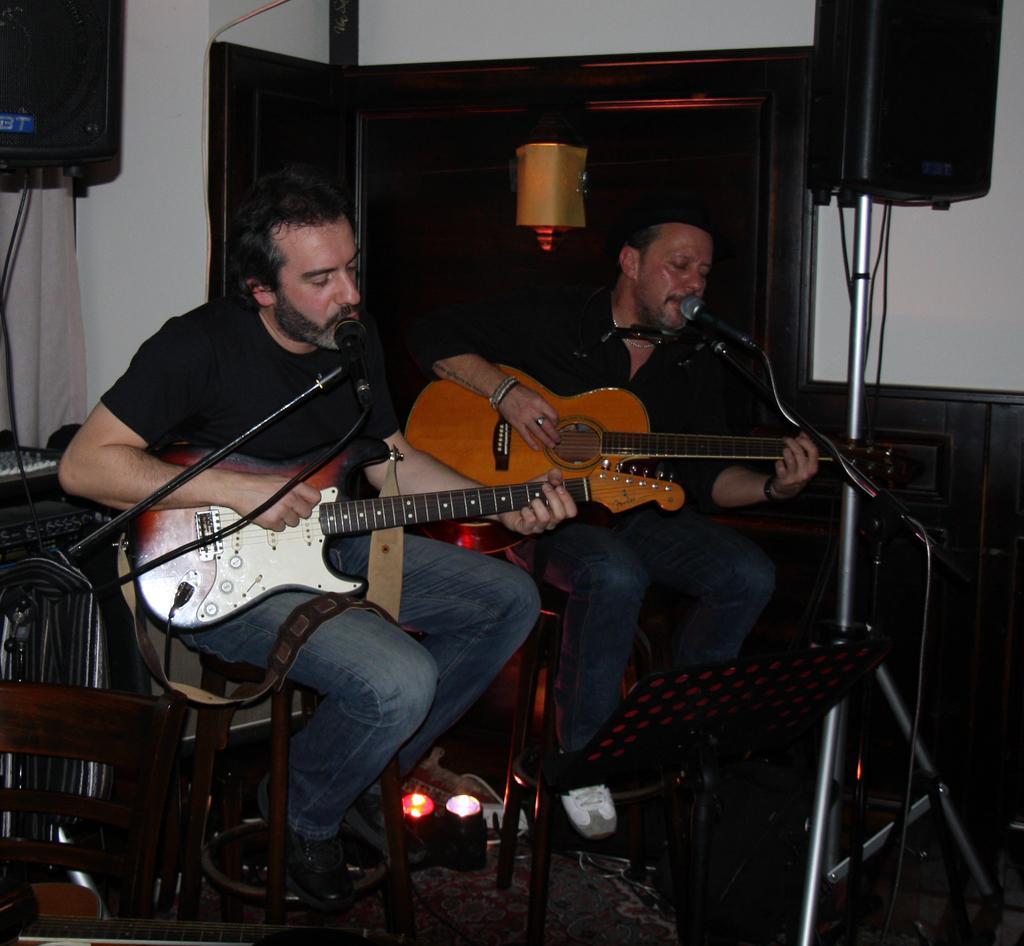How would you summarize this image in a sentence or two? In this image I see 2 men and both of them are holding the guitar and both of them are sitting in front of a mic. In the background I see some equipment, wall and light over here. 